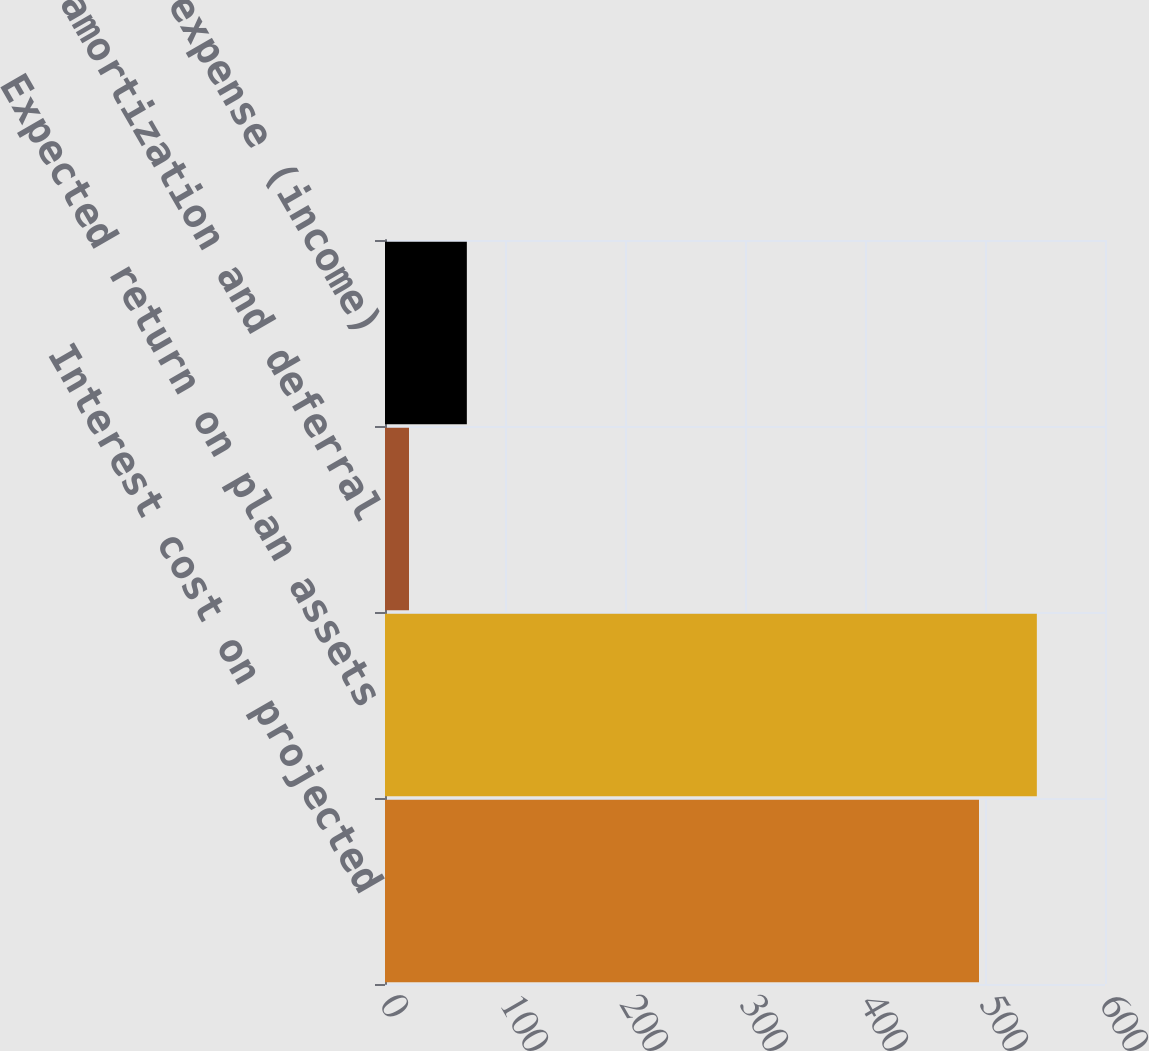Convert chart. <chart><loc_0><loc_0><loc_500><loc_500><bar_chart><fcel>Interest cost on projected<fcel>Expected return on plan assets<fcel>Net amortization and deferral<fcel>Net pension expense (income)<nl><fcel>495<fcel>543.2<fcel>20<fcel>68.2<nl></chart> 